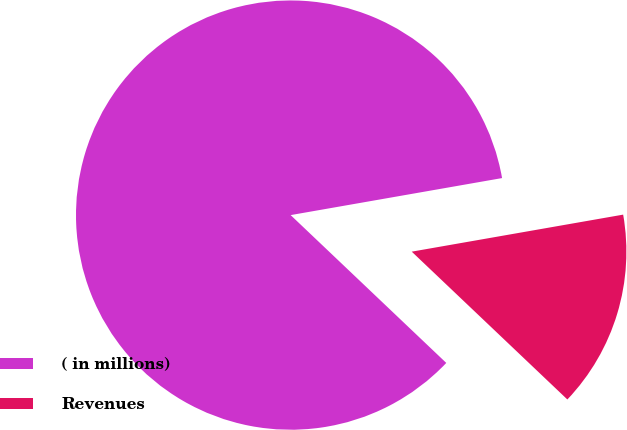Convert chart. <chart><loc_0><loc_0><loc_500><loc_500><pie_chart><fcel>( in millions)<fcel>Revenues<nl><fcel>85.15%<fcel>14.85%<nl></chart> 